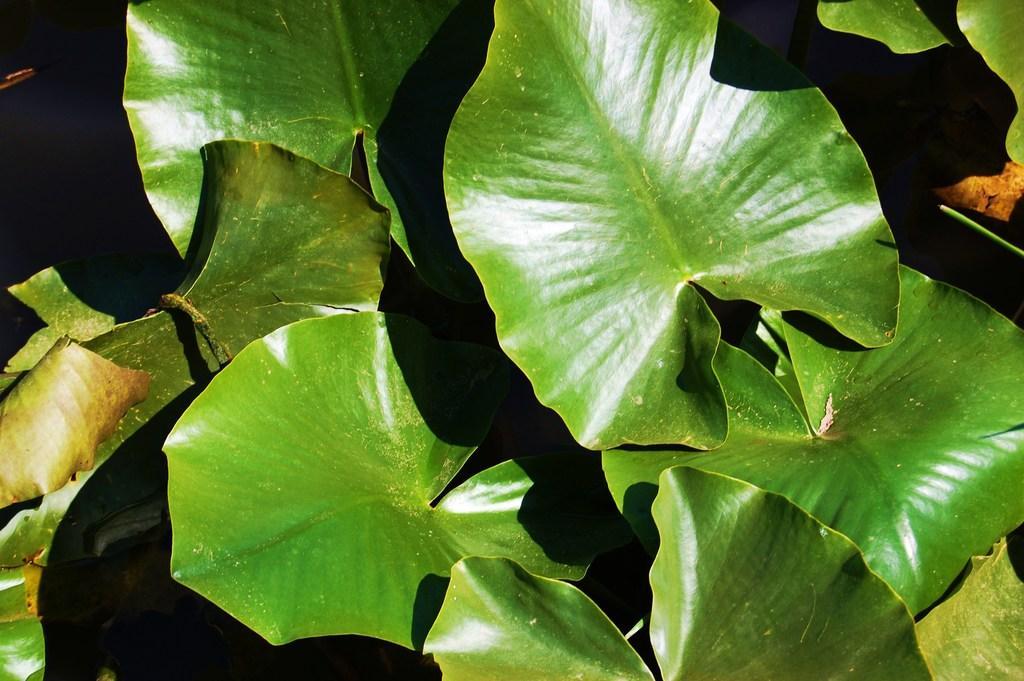How would you summarize this image in a sentence or two? In the foreground of this image, there are leaves of the plants. 